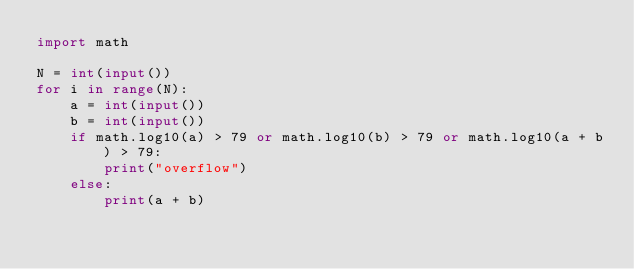Convert code to text. <code><loc_0><loc_0><loc_500><loc_500><_Python_>import math

N = int(input())
for i in range(N):
    a = int(input())
    b = int(input())
    if math.log10(a) > 79 or math.log10(b) > 79 or math.log10(a + b) > 79:
        print("overflow")
    else:
        print(a + b)</code> 